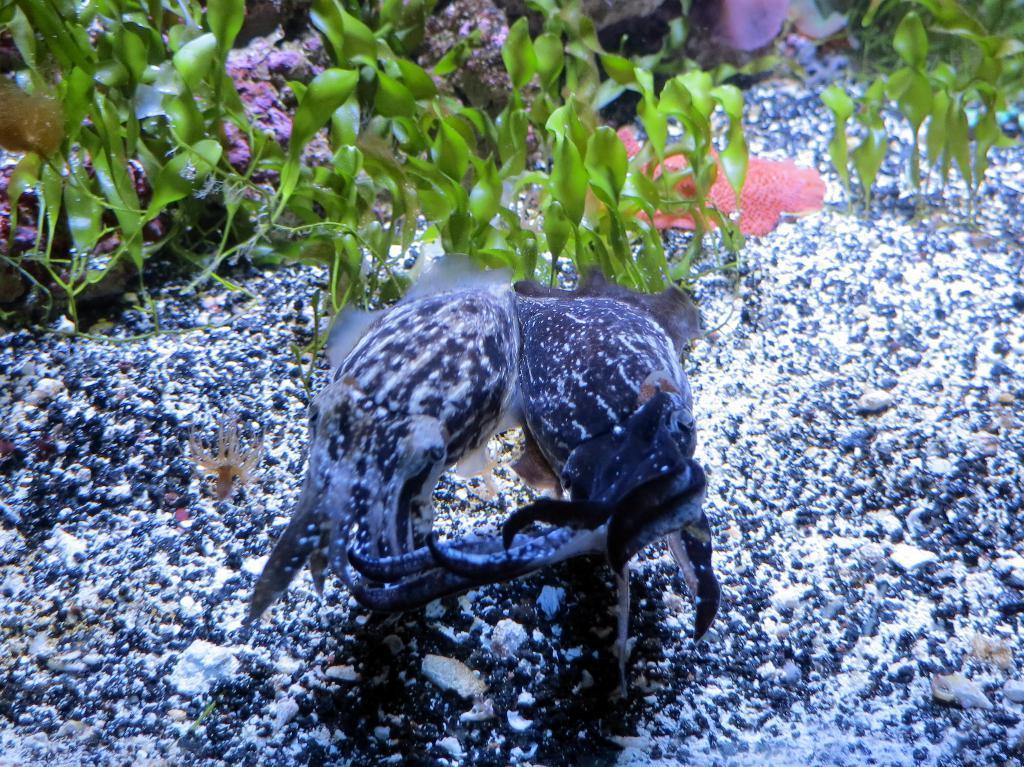In one or two sentences, can you explain what this image depicts? In this image we can see water animals and plants. 